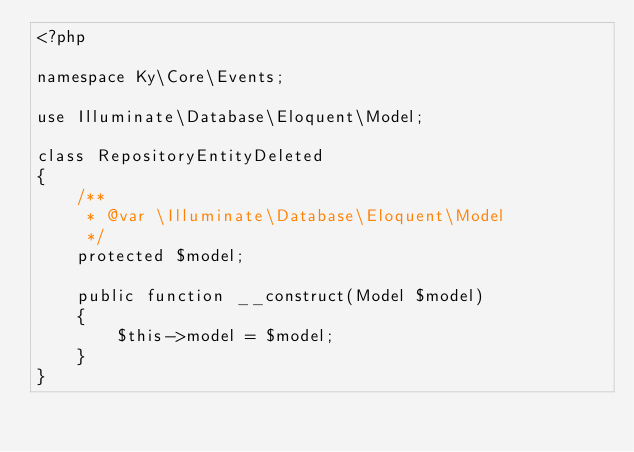Convert code to text. <code><loc_0><loc_0><loc_500><loc_500><_PHP_><?php

namespace Ky\Core\Events;

use Illuminate\Database\Eloquent\Model;

class RepositoryEntityDeleted
{
    /**
     * @var \Illuminate\Database\Eloquent\Model
     */
    protected $model;

    public function __construct(Model $model)
    {
        $this->model = $model;
    }
}
</code> 